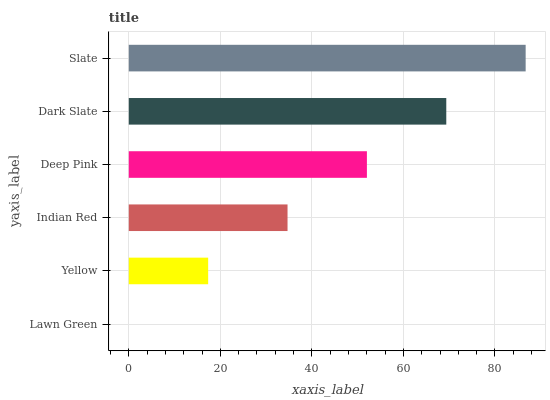Is Lawn Green the minimum?
Answer yes or no. Yes. Is Slate the maximum?
Answer yes or no. Yes. Is Yellow the minimum?
Answer yes or no. No. Is Yellow the maximum?
Answer yes or no. No. Is Yellow greater than Lawn Green?
Answer yes or no. Yes. Is Lawn Green less than Yellow?
Answer yes or no. Yes. Is Lawn Green greater than Yellow?
Answer yes or no. No. Is Yellow less than Lawn Green?
Answer yes or no. No. Is Deep Pink the high median?
Answer yes or no. Yes. Is Indian Red the low median?
Answer yes or no. Yes. Is Slate the high median?
Answer yes or no. No. Is Dark Slate the low median?
Answer yes or no. No. 